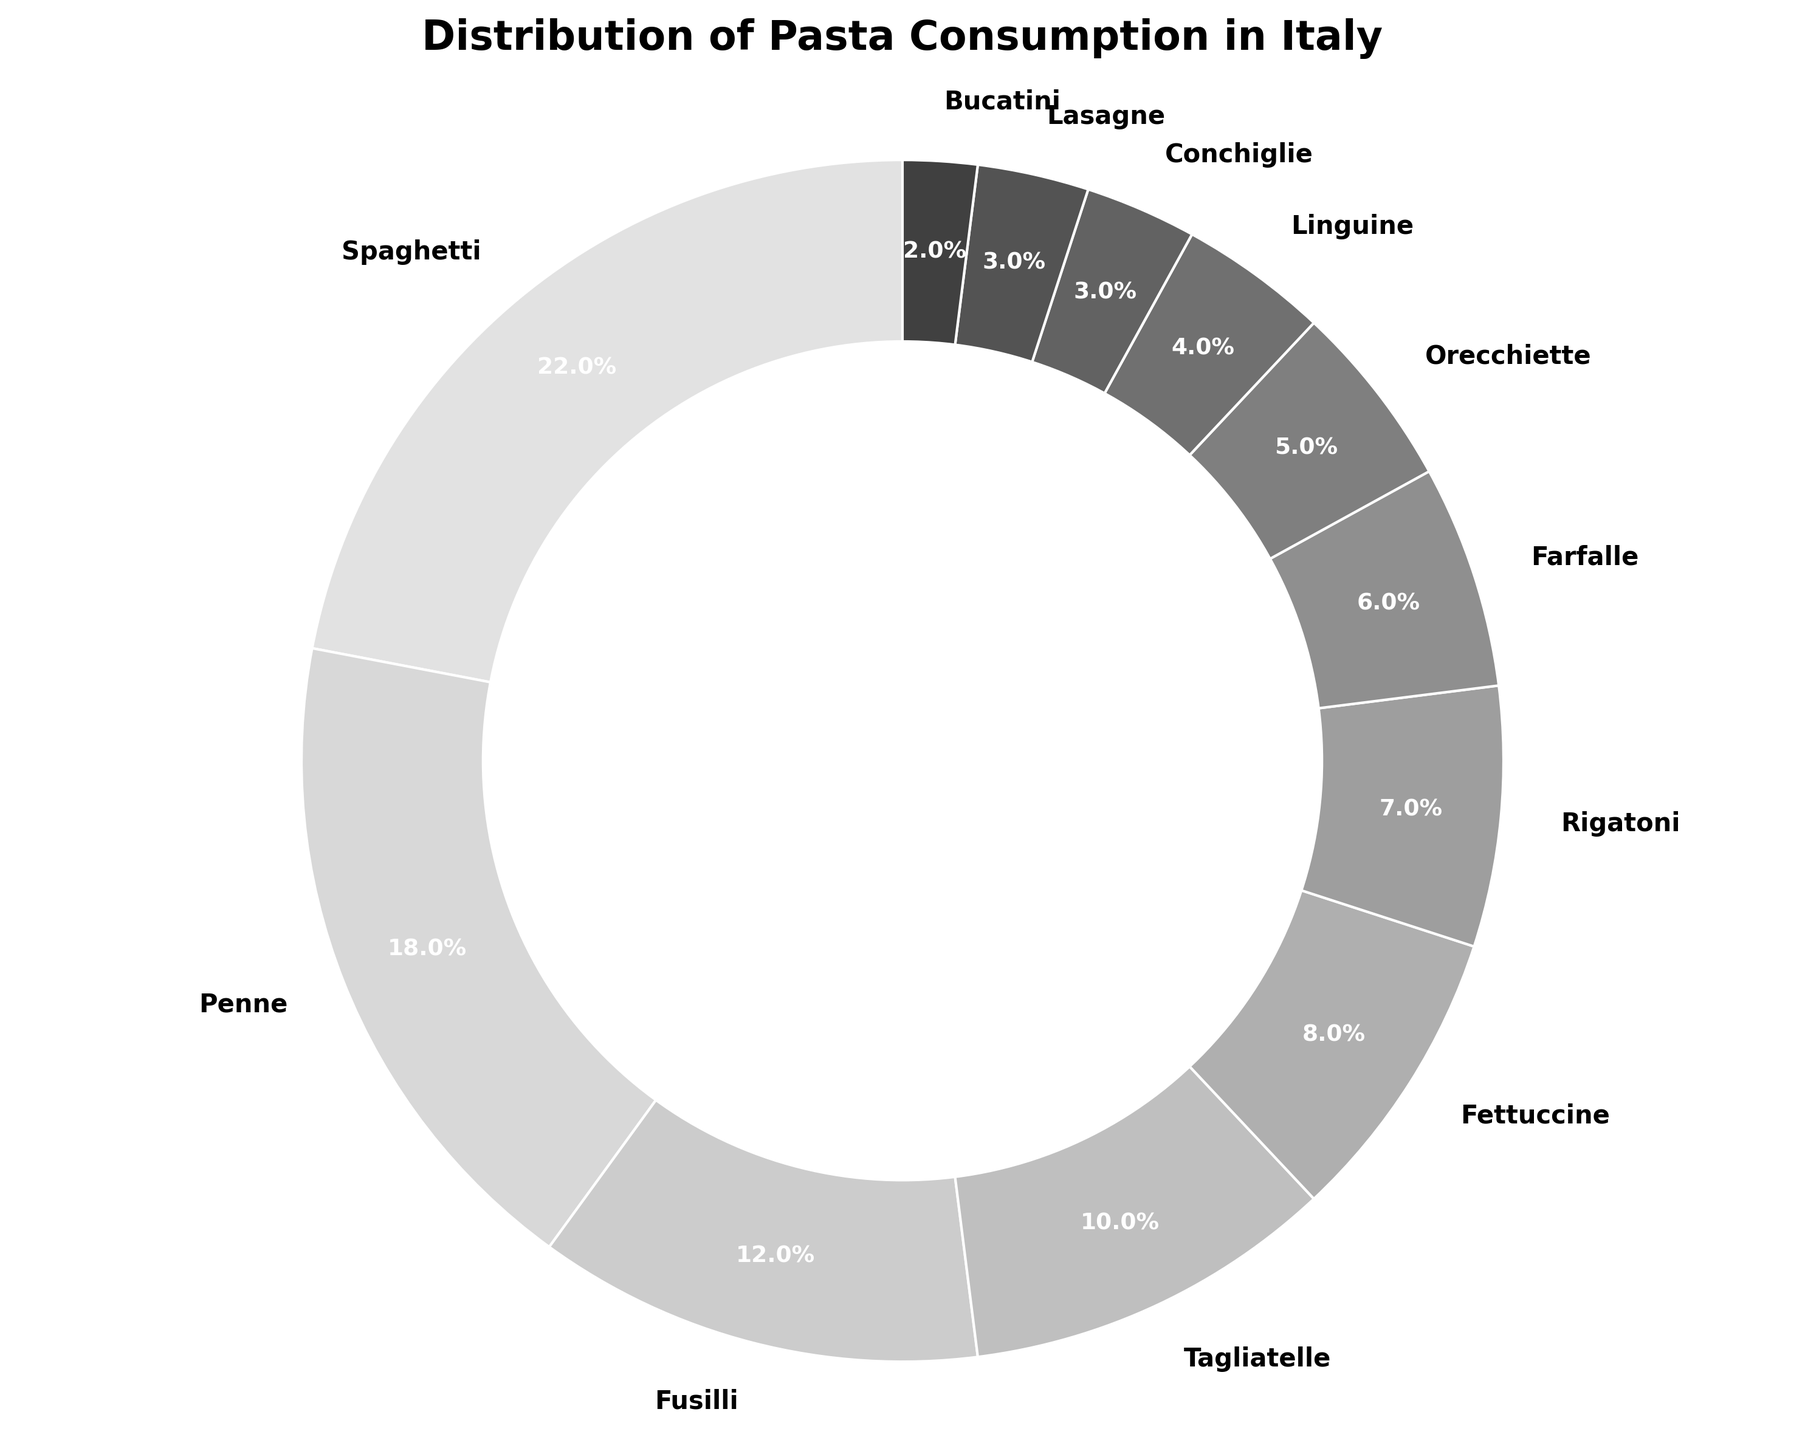How much of the total pasta consumption is accounted for by Spaghetti and Penne combined? Add the percentages of Spaghetti and Penne: 22% + 18% = 40%.
Answer: 40% Which type of pasta has a higher percentage of consumption: Fusilli or Tagliatelle? Compare the percentages of Fusilli and Tagliatelle: Fusilli has 12%, Tagliatelle has 10%. Fusilli is higher.
Answer: Fusilli What is the difference in consumption percentage between the most and least consumed pasta types? Subtract the percentage of the least consumed type (Bucatini, 2%) from the most consumed type (Spaghetti, 22%): 22% - 2% = 20%.
Answer: 20% How do the combined consumptions of Rigatoni, Farfalle, and Orecchiette compare to Spaghetti? Add the percentages of Rigatoni, Farfalle, and Orecchiette: 7% + 6% + 5% = 18%. Compare this to Spaghetti's 22%. Rigatoni, Farfalle, and Orecchiette combined are less than Spaghetti.
Answer: Less Which pasta type falls exactly in the middle if we order them by percentage consumption from highest to lowest? Order the pasta types by percentage and find the middle value: [Spaghetti (22%), Penne (18%), Fusilli (12%), Tagliatelle (10%), Fettuccine (8%), Rigatoni (7%), Farfalle (6%), Orecchiette (5%), Linguine (4%), Conchiglie (3%), Lasagne (3%), Bucatini (2%)]. The middle is Fettuccine (8%).
Answer: Fettuccine Which has a higher percentage: Fettuccine or the combined percentage of Conchiglie and Lasagne? Compare percentages: Fettuccine (8%) vs Conchiglie (3%) + Lasagne (3%) = 6%. Fettuccine is higher.
Answer: Fettuccine By how much does the percentage of Spaghetti exceed the average percentage of all pasta types? Calculate the average: (22% + 18% + 12% + 10% + 8% + 7% + 6% + 5% + 4% + 3% + 3% + 2%) / 12 = 8.75%. The difference between Spaghetti and this average is 22% - 8.75% = 13.25%.
Answer: 13.25% Which three types of pasta form the smallest wedges in the pie chart? The smallest percentages are 2%, 3%, and 3%. The corresponding types are Bucatini, Conchiglie, and Lasagne.
Answer: Bucatini, Conchiglie, Lasagne What is the total percentage accounted for by the types of pasta with single-digit percentages? Add the percentages of Tagliatelle (10%), Fettuccine (8%), Rigatoni (7%), Farfalle (6%), Orecchiette (5%), Linguine (4%), Conchiglie (3%), Lasagne (3%), and Bucatini (2%): 10% + 8% + 7% + 6% + 5% + 4% + 3% + 3% + 2% = 48%.
Answer: 48% What is the consumption percentage of the least consumed pasta compared to the most consumed one? Calculate the ratio of Bucatini (2%) to Spaghetti (22%): 2% / 22% ≈ 0.091 or 9.1%
Answer: 9.1% 